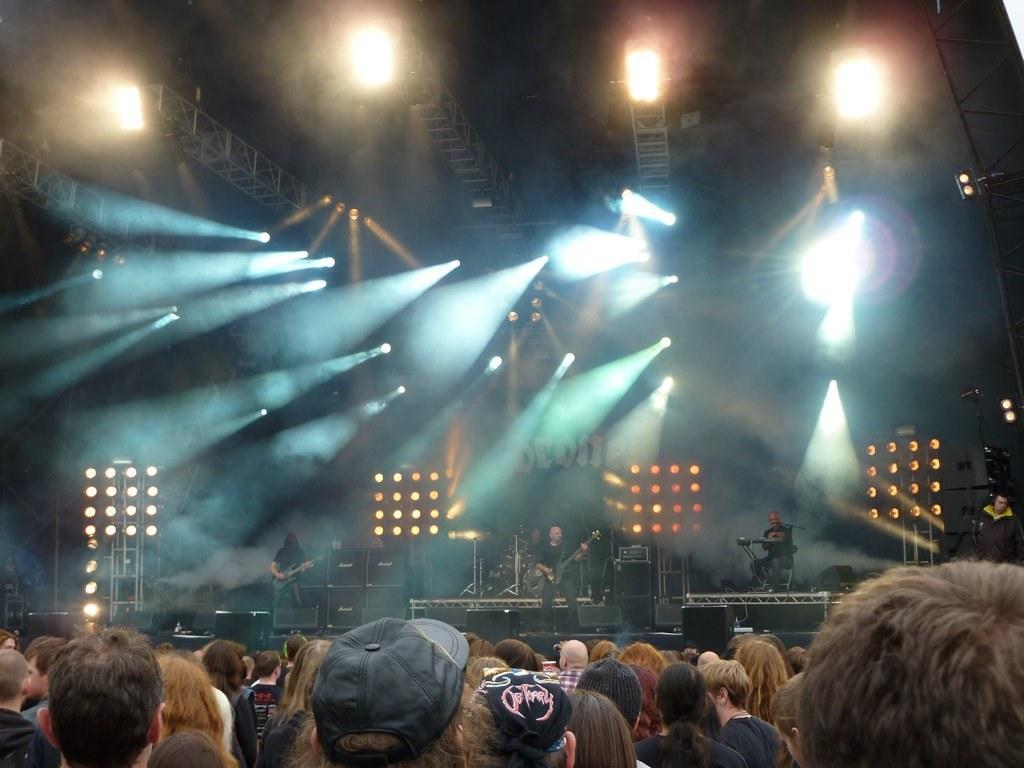Please provide a concise description of this image. In this image I can see group of people, background I can see few persons playing few musical instruments and I can also see few lights and poles. 